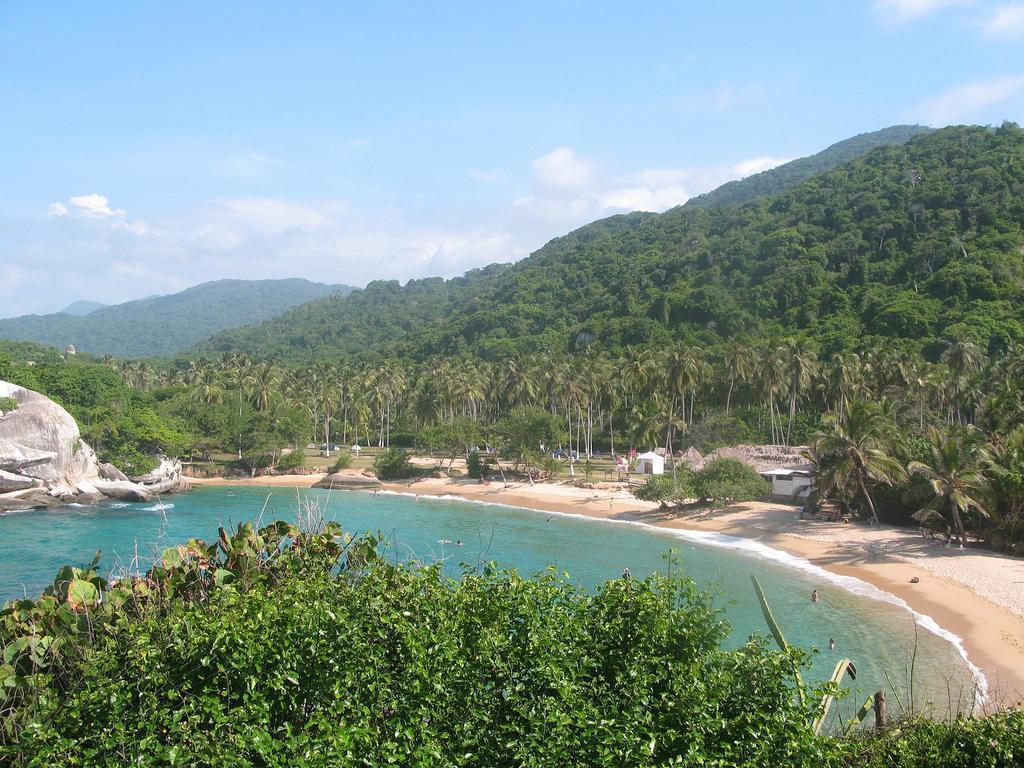Could you give a brief overview of what you see in this image? In this picture we can see trees and water and in the background we can see sheds, rocks, mountains and sky with clouds. 